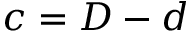<formula> <loc_0><loc_0><loc_500><loc_500>c = D - d</formula> 